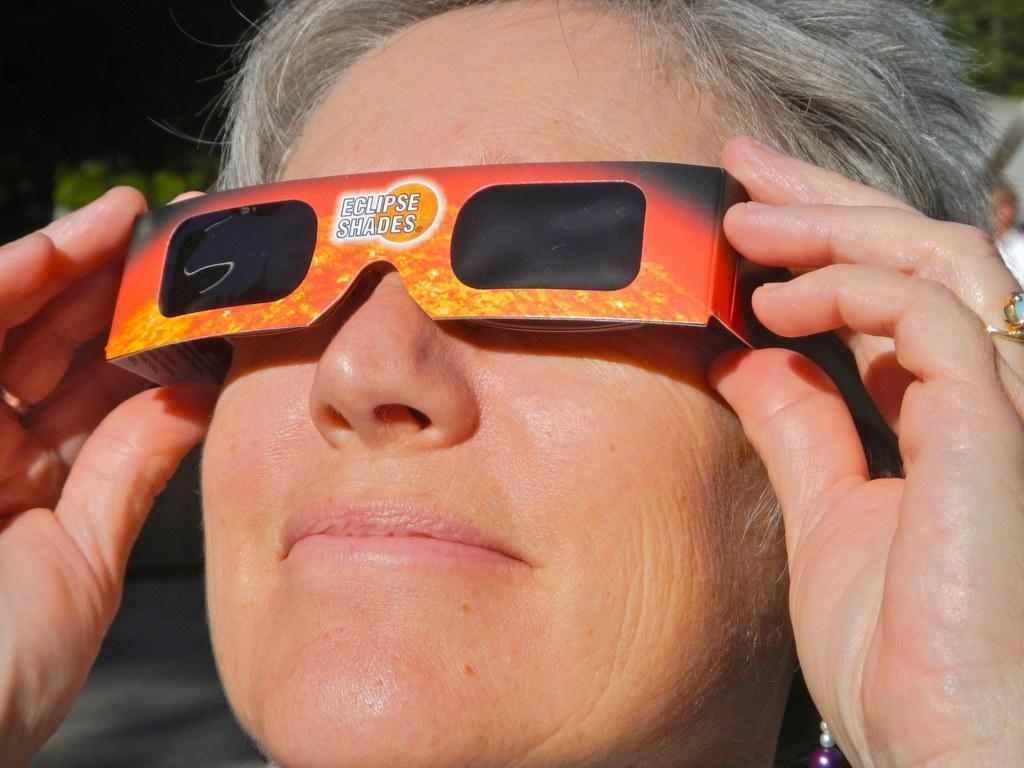Could you give a brief overview of what you see in this image? In this image there is a person with shades on his eyes is staring at something. 